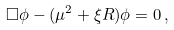<formula> <loc_0><loc_0><loc_500><loc_500>\Box \phi - ( \mu ^ { 2 } + \xi R ) \phi = 0 \, ,</formula> 